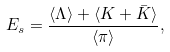<formula> <loc_0><loc_0><loc_500><loc_500>E _ { s } = \frac { \langle \Lambda \rangle + \langle K + \bar { K } \rangle } { \langle \pi \rangle } ,</formula> 